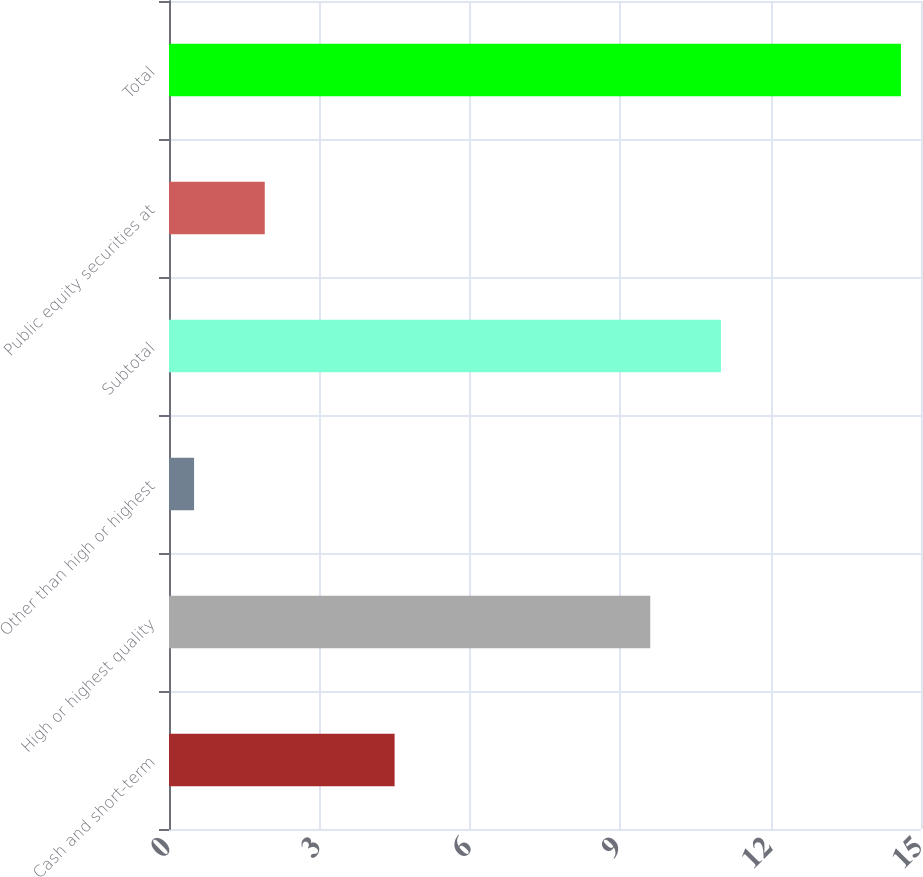Convert chart. <chart><loc_0><loc_0><loc_500><loc_500><bar_chart><fcel>Cash and short-term<fcel>High or highest quality<fcel>Other than high or highest<fcel>Subtotal<fcel>Public equity securities at<fcel>Total<nl><fcel>4.5<fcel>9.6<fcel>0.5<fcel>11.01<fcel>1.91<fcel>14.6<nl></chart> 